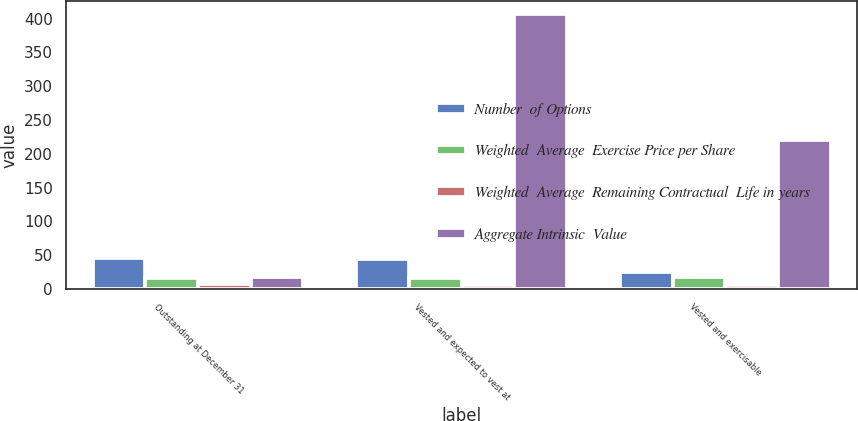Convert chart to OTSL. <chart><loc_0><loc_0><loc_500><loc_500><stacked_bar_chart><ecel><fcel>Outstanding at December 31<fcel>Vested and expected to vest at<fcel>Vested and exercisable<nl><fcel>Number  of Options<fcel>46<fcel>44<fcel>25<nl><fcel>Weighted  Average  Exercise Price per Share<fcel>16.74<fcel>16.76<fcel>17.17<nl><fcel>Weighted  Average  Remaining Contractual  Life in years<fcel>6.83<fcel>6.74<fcel>5.33<nl><fcel>Aggregate Intrinsic  Value<fcel>17.17<fcel>406<fcel>220<nl></chart> 